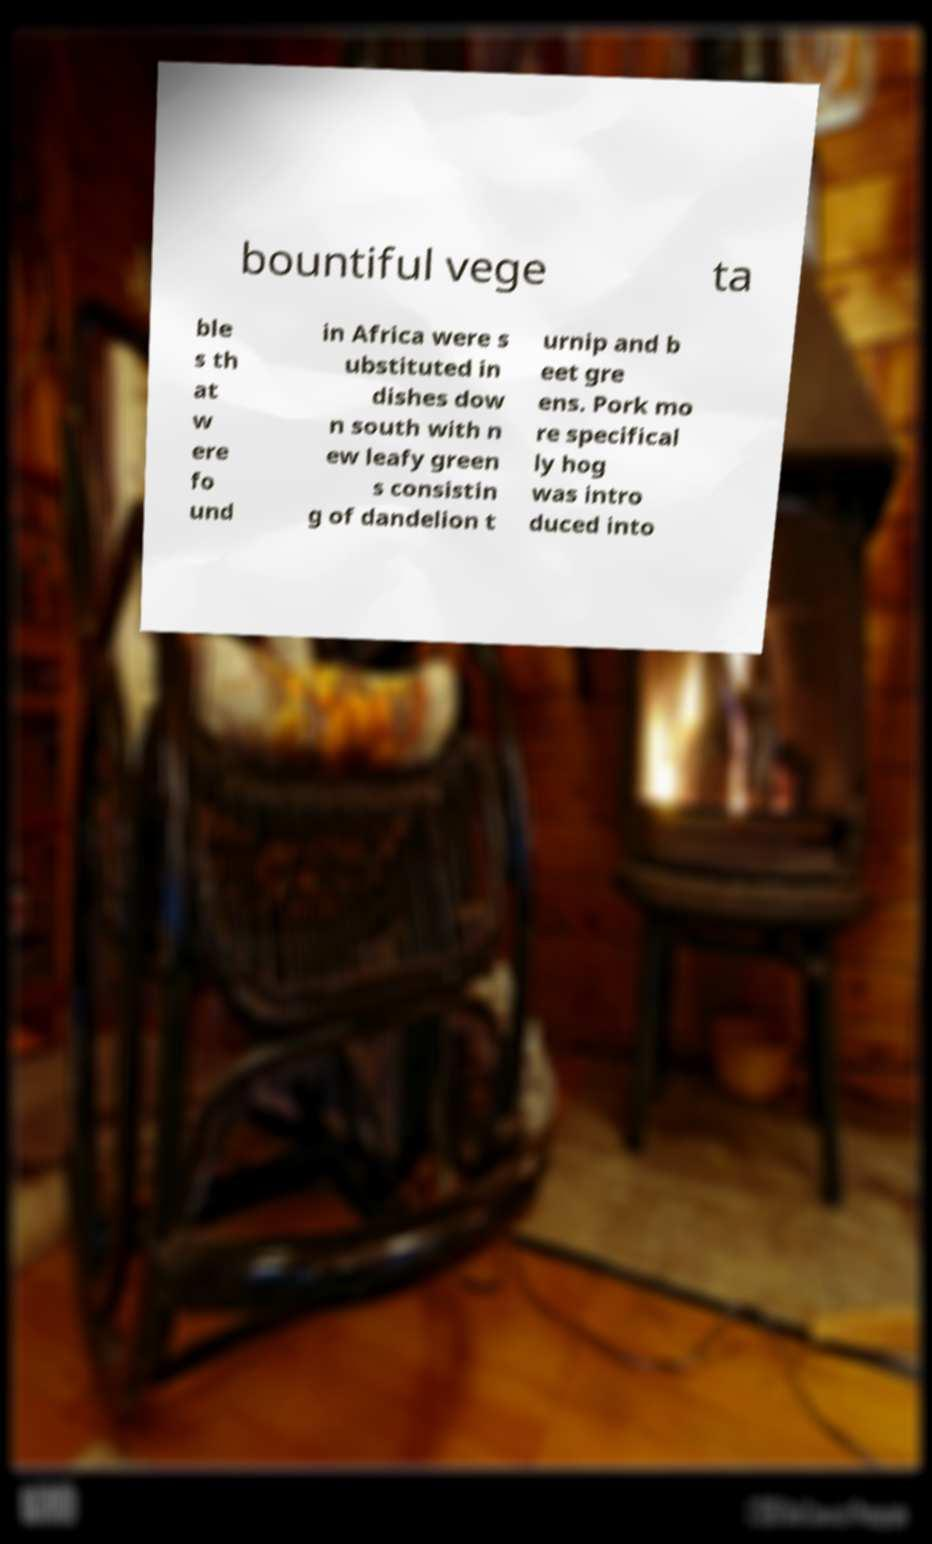Could you extract and type out the text from this image? bountiful vege ta ble s th at w ere fo und in Africa were s ubstituted in dishes dow n south with n ew leafy green s consistin g of dandelion t urnip and b eet gre ens. Pork mo re specifical ly hog was intro duced into 